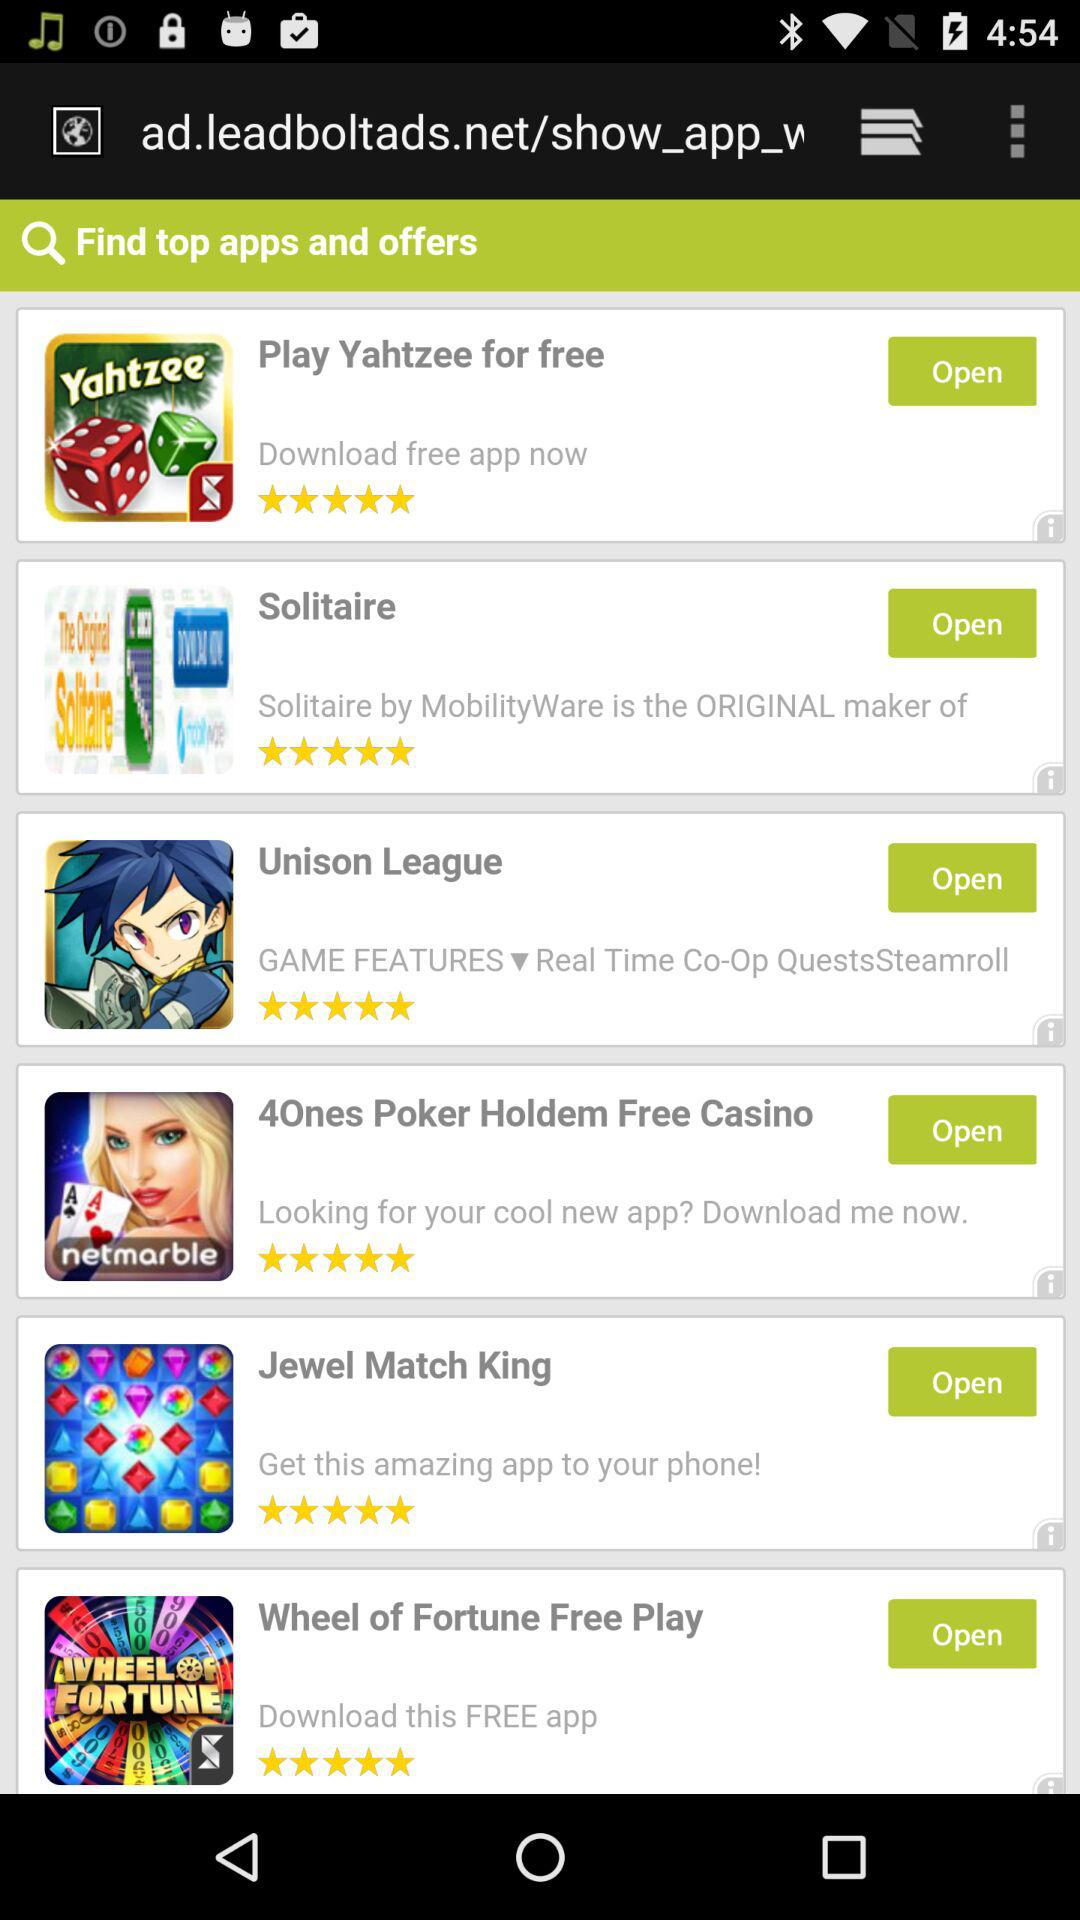How many stars are given to "Jewel Match King"? There are 5 stars. 